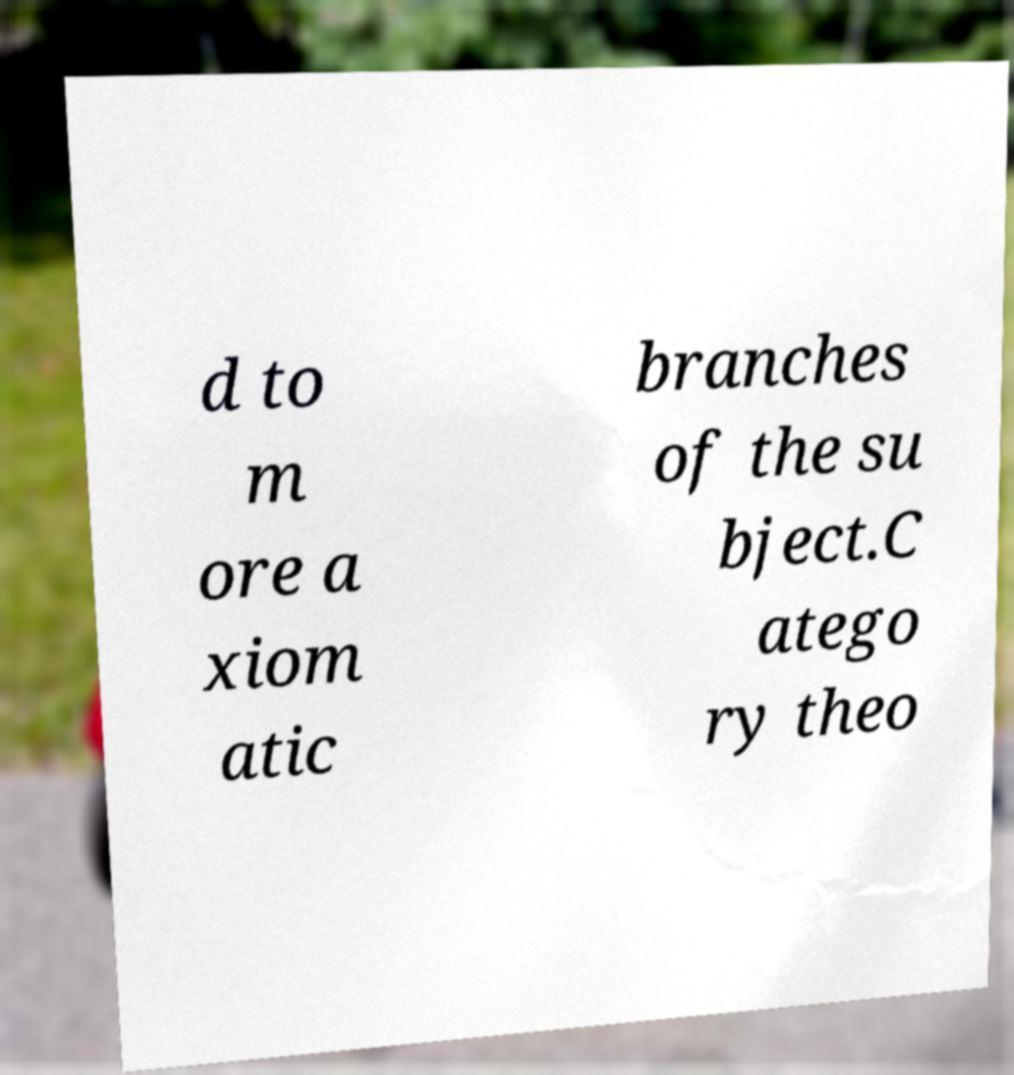Could you extract and type out the text from this image? d to m ore a xiom atic branches of the su bject.C atego ry theo 